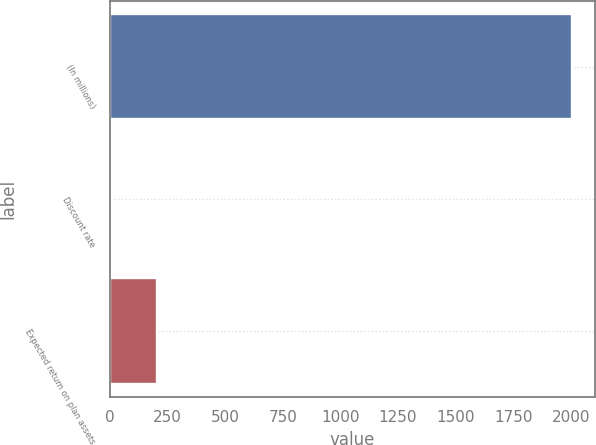Convert chart. <chart><loc_0><loc_0><loc_500><loc_500><bar_chart><fcel>(In millions)<fcel>Discount rate<fcel>Expected return on plan assets<nl><fcel>2006<fcel>5.68<fcel>205.71<nl></chart> 